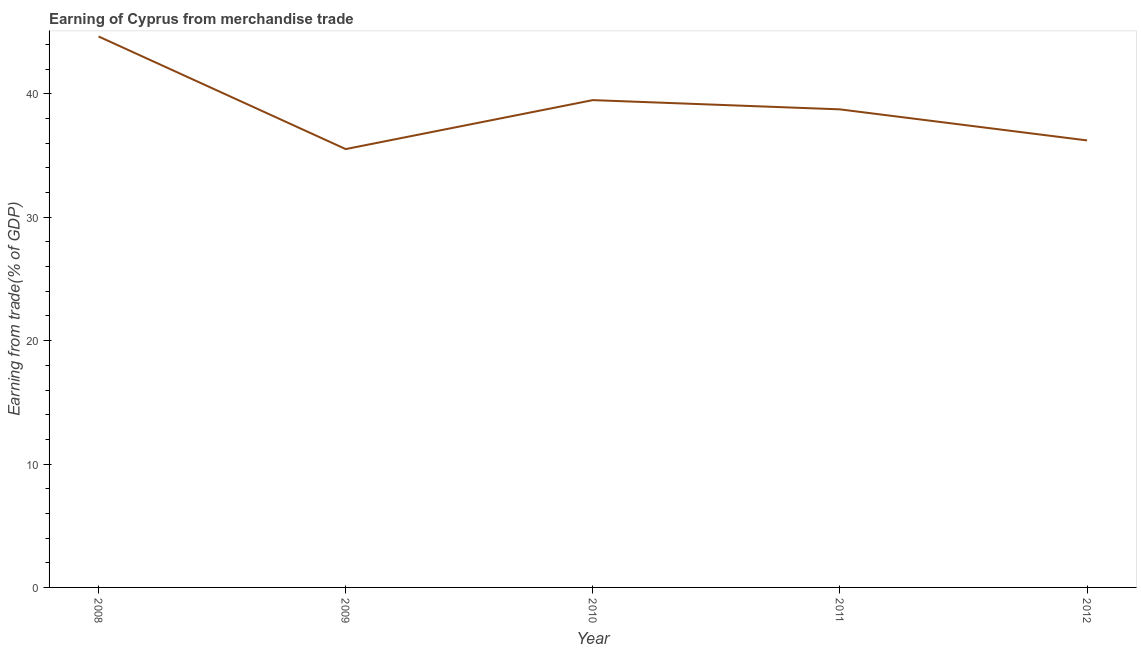What is the earning from merchandise trade in 2010?
Make the answer very short. 39.49. Across all years, what is the maximum earning from merchandise trade?
Provide a succinct answer. 44.65. Across all years, what is the minimum earning from merchandise trade?
Your answer should be compact. 35.53. In which year was the earning from merchandise trade maximum?
Provide a short and direct response. 2008. What is the sum of the earning from merchandise trade?
Your answer should be compact. 194.65. What is the difference between the earning from merchandise trade in 2011 and 2012?
Your answer should be compact. 2.52. What is the average earning from merchandise trade per year?
Keep it short and to the point. 38.93. What is the median earning from merchandise trade?
Give a very brief answer. 38.74. Do a majority of the years between 2009 and 2012 (inclusive) have earning from merchandise trade greater than 18 %?
Provide a succinct answer. Yes. What is the ratio of the earning from merchandise trade in 2008 to that in 2011?
Offer a terse response. 1.15. What is the difference between the highest and the second highest earning from merchandise trade?
Offer a terse response. 5.16. Is the sum of the earning from merchandise trade in 2008 and 2009 greater than the maximum earning from merchandise trade across all years?
Your response must be concise. Yes. What is the difference between the highest and the lowest earning from merchandise trade?
Your answer should be very brief. 9.13. In how many years, is the earning from merchandise trade greater than the average earning from merchandise trade taken over all years?
Offer a terse response. 2. How many lines are there?
Offer a terse response. 1. How many years are there in the graph?
Make the answer very short. 5. What is the difference between two consecutive major ticks on the Y-axis?
Make the answer very short. 10. Are the values on the major ticks of Y-axis written in scientific E-notation?
Ensure brevity in your answer.  No. Does the graph contain grids?
Your response must be concise. No. What is the title of the graph?
Offer a very short reply. Earning of Cyprus from merchandise trade. What is the label or title of the Y-axis?
Your answer should be compact. Earning from trade(% of GDP). What is the Earning from trade(% of GDP) of 2008?
Give a very brief answer. 44.65. What is the Earning from trade(% of GDP) of 2009?
Keep it short and to the point. 35.53. What is the Earning from trade(% of GDP) in 2010?
Your response must be concise. 39.49. What is the Earning from trade(% of GDP) of 2011?
Give a very brief answer. 38.74. What is the Earning from trade(% of GDP) in 2012?
Offer a very short reply. 36.23. What is the difference between the Earning from trade(% of GDP) in 2008 and 2009?
Provide a succinct answer. 9.13. What is the difference between the Earning from trade(% of GDP) in 2008 and 2010?
Ensure brevity in your answer.  5.16. What is the difference between the Earning from trade(% of GDP) in 2008 and 2011?
Keep it short and to the point. 5.91. What is the difference between the Earning from trade(% of GDP) in 2008 and 2012?
Make the answer very short. 8.43. What is the difference between the Earning from trade(% of GDP) in 2009 and 2010?
Offer a terse response. -3.97. What is the difference between the Earning from trade(% of GDP) in 2009 and 2011?
Offer a very short reply. -3.22. What is the difference between the Earning from trade(% of GDP) in 2009 and 2012?
Offer a very short reply. -0.7. What is the difference between the Earning from trade(% of GDP) in 2010 and 2011?
Provide a succinct answer. 0.75. What is the difference between the Earning from trade(% of GDP) in 2010 and 2012?
Your answer should be very brief. 3.27. What is the difference between the Earning from trade(% of GDP) in 2011 and 2012?
Give a very brief answer. 2.52. What is the ratio of the Earning from trade(% of GDP) in 2008 to that in 2009?
Provide a short and direct response. 1.26. What is the ratio of the Earning from trade(% of GDP) in 2008 to that in 2010?
Keep it short and to the point. 1.13. What is the ratio of the Earning from trade(% of GDP) in 2008 to that in 2011?
Provide a succinct answer. 1.15. What is the ratio of the Earning from trade(% of GDP) in 2008 to that in 2012?
Offer a very short reply. 1.23. What is the ratio of the Earning from trade(% of GDP) in 2009 to that in 2011?
Provide a succinct answer. 0.92. What is the ratio of the Earning from trade(% of GDP) in 2010 to that in 2011?
Make the answer very short. 1.02. What is the ratio of the Earning from trade(% of GDP) in 2010 to that in 2012?
Provide a succinct answer. 1.09. What is the ratio of the Earning from trade(% of GDP) in 2011 to that in 2012?
Make the answer very short. 1.07. 